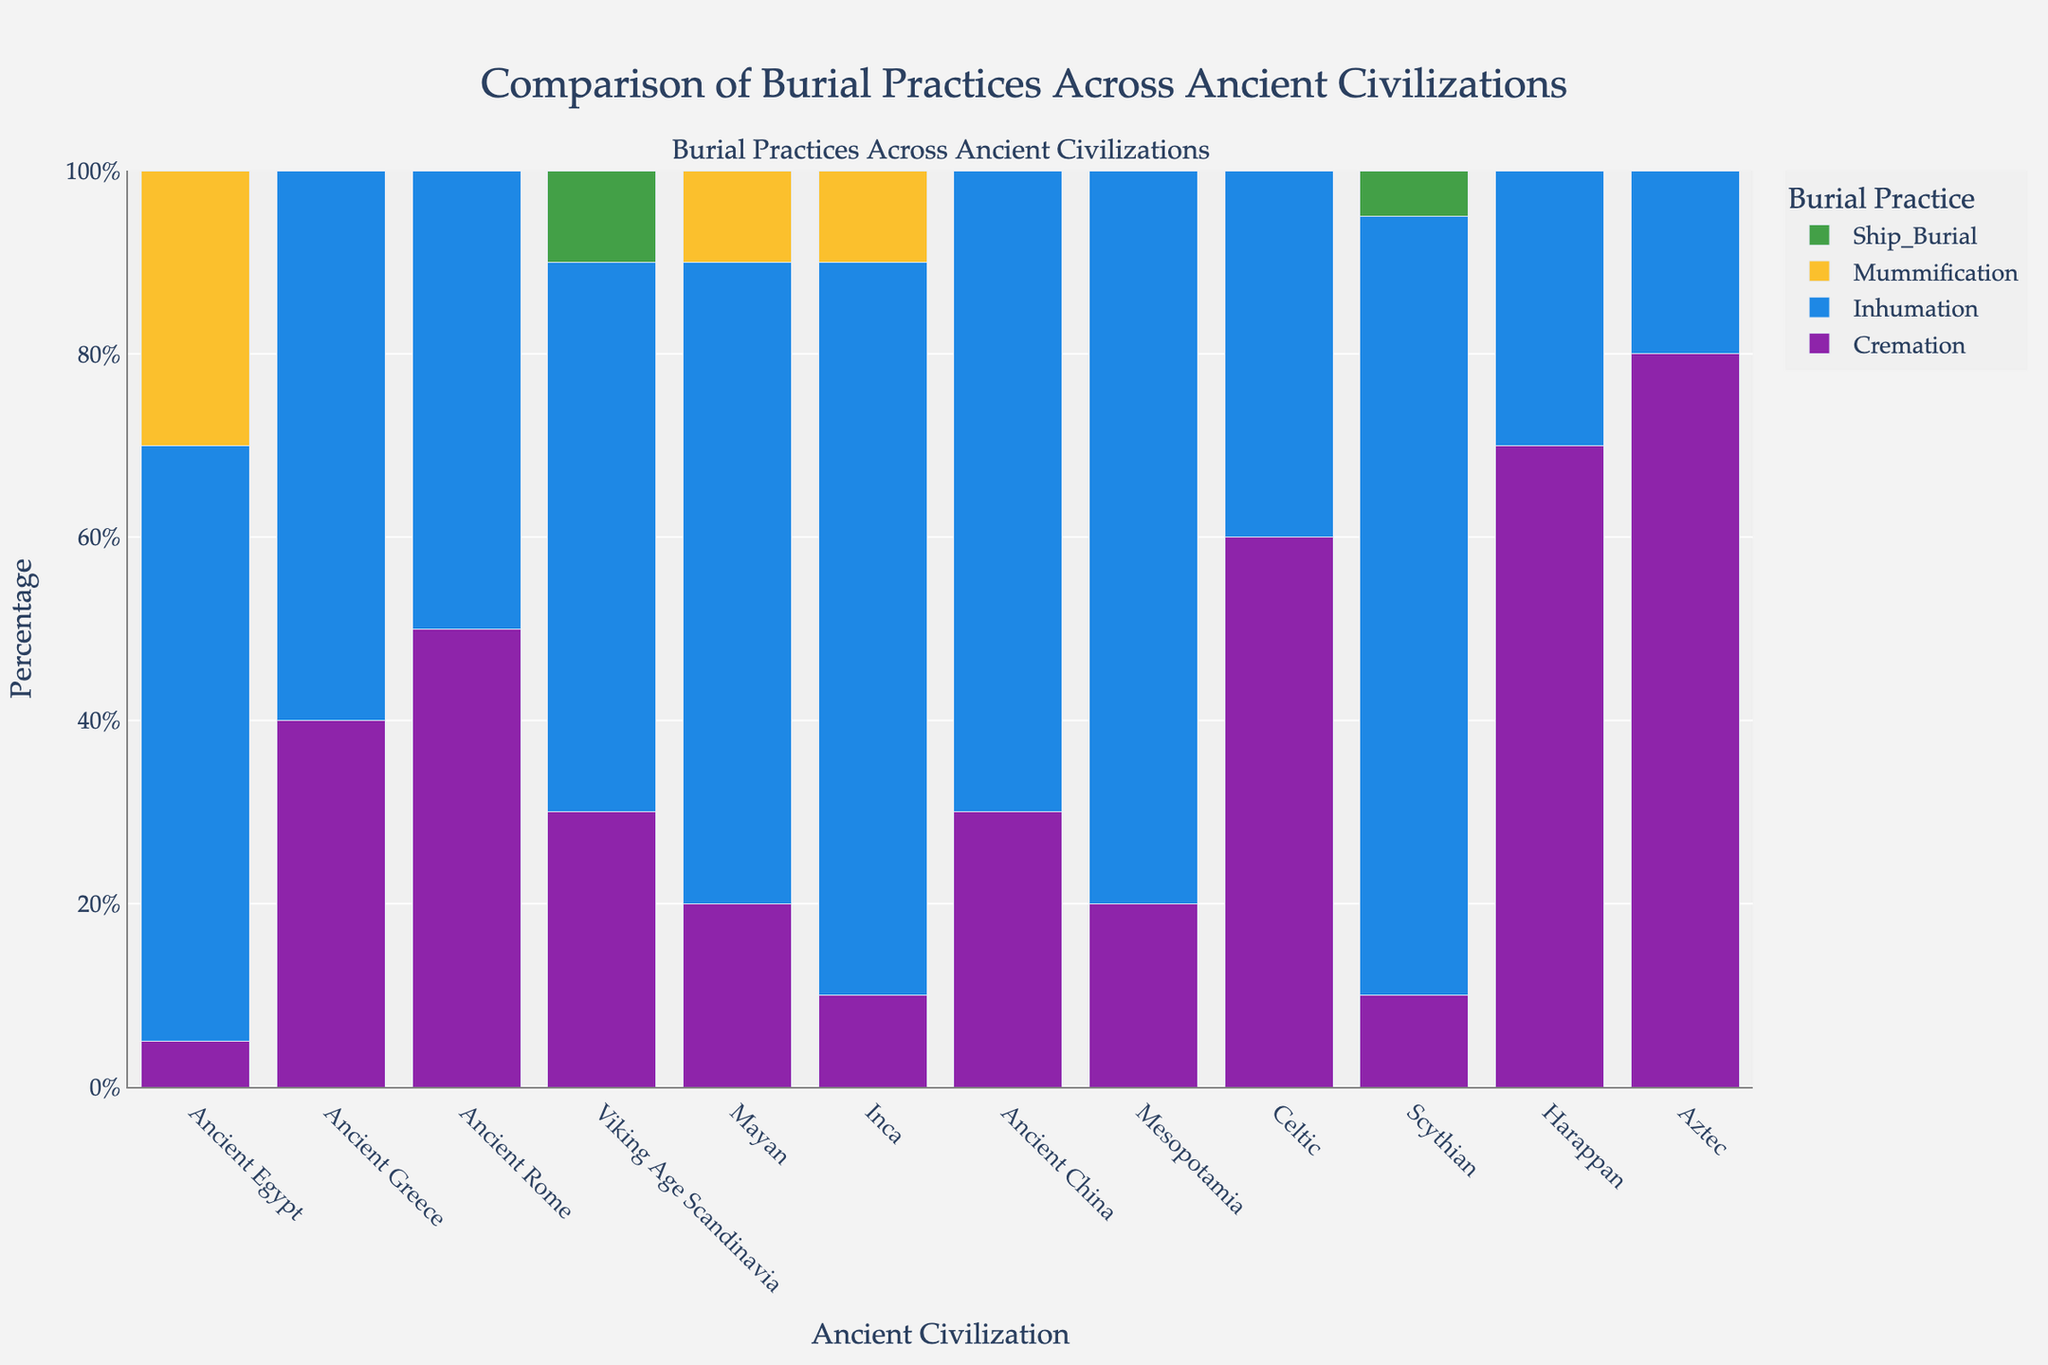Which civilization practices cremation the most? To determine which civilization practices cremation the most, look at the "Cremation" category in the bar chart and identify the tallest bar.
Answer: Aztec Which civilization has an equal percentage for cremation and inhumation practices? Find the civilization where the heights of the bars for both cremation and inhumation are equal.
Answer: Ancient Rome What is the combined percentage of Mummification practice for the Mayan and Inca civilizations? Identify the "Mummification" bars for the Mayan and Inca civilizations, and add their heights together (10% + 10%).
Answer: 20% Compare the inhumation percentage of Ancient Egypt to that of Mesopotamia. Which civilization has a higher percentage? Look at the "Inhumation" bars for Ancient Egypt and Mesopotamia and compare their heights.
Answer: Mesopotamia What is the total percentage of burial practices (combined percentage of all practices) for the Viking Age Scandinavia? Add the heights of all bars for Viking Age Scandinavia (Cremation + Inhumation + Ship_Burial) (30% + 60% + 10%).
Answer: 100% Which civilization's burial practices are mostly comprised of inhumation, with no other significant practices (only inhumation practices are prominent)? Find the civilization with a significantly tall bar for "Inhumation" and very small or zero bars for other practices.
Answer: Mesopotamia What is the difference in the percentage of ship burial between Viking Age Scandinavia and Scythian? Identify the "Ship_Burial_Percentage" bars for both Viking Age Scandinavia and Scythian and find the difference (10% - 5%).
Answer: 5% Which practice is used exclusively by one civilization and not the others? Look for a bar that is present for one civilization but absent for all others. Ship burial in Viking Age Scandinavia meets this condition.
Answer: Ship Burial What is the combined percentage of inhumation and mummification practices for Ancient Egypt? Add the heights of bars for "Inhumation_Percentage" and "Mummification_Percentage" for Ancient Egypt (65% + 30%).
Answer: 95% Which civilization, other than Aztec, has the highest cremation percentage? Identify the civilizations with the second tallest bar in the "Cremation_Percentage" category, after Aztec.
Answer: Celtic 